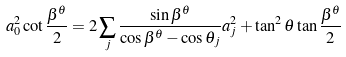<formula> <loc_0><loc_0><loc_500><loc_500>a _ { 0 } ^ { 2 } \cot \frac { \beta ^ { \theta } } { 2 } = 2 \sum _ { j } \frac { \sin \beta ^ { \theta } } { \cos \beta ^ { \theta } - \cos \theta _ { j } } a _ { j } ^ { 2 } + \tan ^ { 2 } \theta \tan \frac { \beta ^ { \theta } } { 2 }</formula> 